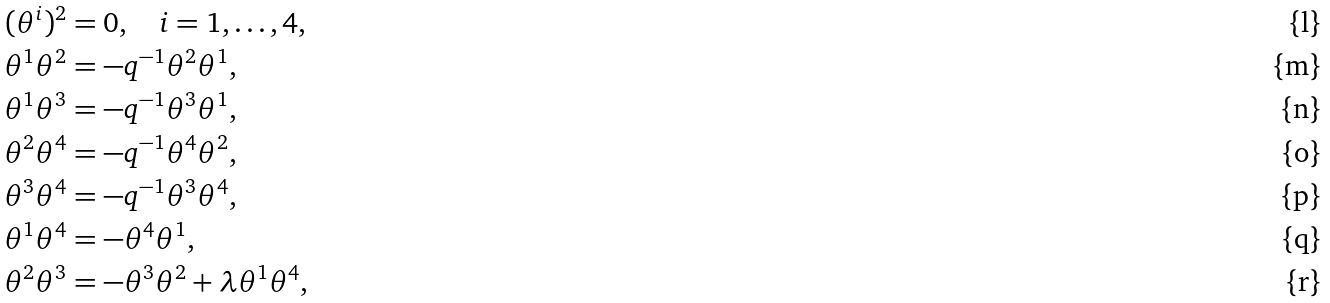Convert formula to latex. <formula><loc_0><loc_0><loc_500><loc_500>( \theta ^ { i } ) ^ { 2 } & = 0 , \quad i = 1 , \dots , 4 , \\ \theta ^ { 1 } \theta ^ { 2 } & = - q ^ { - 1 } \theta ^ { 2 } \theta ^ { 1 } , \\ \theta ^ { 1 } \theta ^ { 3 } & = - q ^ { - 1 } \theta ^ { 3 } \theta ^ { 1 } , \\ \theta ^ { 2 } \theta ^ { 4 } & = - q ^ { - 1 } \theta ^ { 4 } \theta ^ { 2 } , \\ \theta ^ { 3 } \theta ^ { 4 } & = - q ^ { - 1 } \theta ^ { 3 } \theta ^ { 4 } , \\ \theta ^ { 1 } \theta ^ { 4 } & = - \theta ^ { 4 } \theta ^ { 1 } , \\ \theta ^ { 2 } \theta ^ { 3 } & = - \theta ^ { 3 } \theta ^ { 2 } + \lambda \theta ^ { 1 } \theta ^ { 4 } ,</formula> 